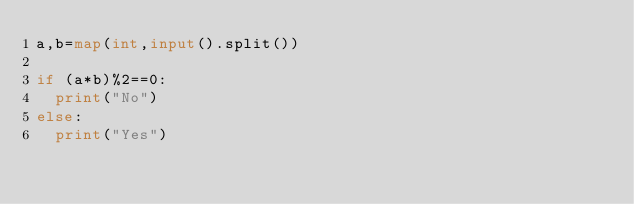Convert code to text. <code><loc_0><loc_0><loc_500><loc_500><_Python_>a,b=map(int,input().split())

if (a*b)%2==0:
  print("No")
else:
  print("Yes")</code> 